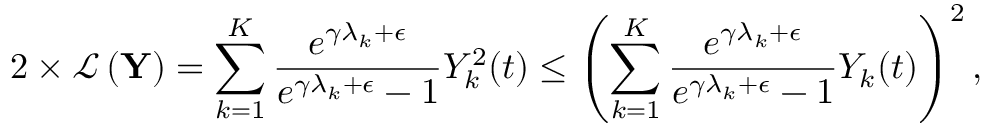Convert formula to latex. <formula><loc_0><loc_0><loc_500><loc_500>2 \times \mathcal { L } \left ( Y \right ) = \sum _ { k = 1 } ^ { K } \frac { e ^ { \gamma \lambda _ { k } + \epsilon } } { e ^ { \gamma \lambda _ { k } + \epsilon } - 1 } Y _ { k } ^ { 2 } ( t ) \leq \left ( \sum _ { k = 1 } ^ { K } \frac { e ^ { \gamma \lambda _ { k } + \epsilon } } { e ^ { \gamma \lambda _ { k } + \epsilon } - 1 } Y _ { k } ( t ) \right ) ^ { 2 } ,</formula> 